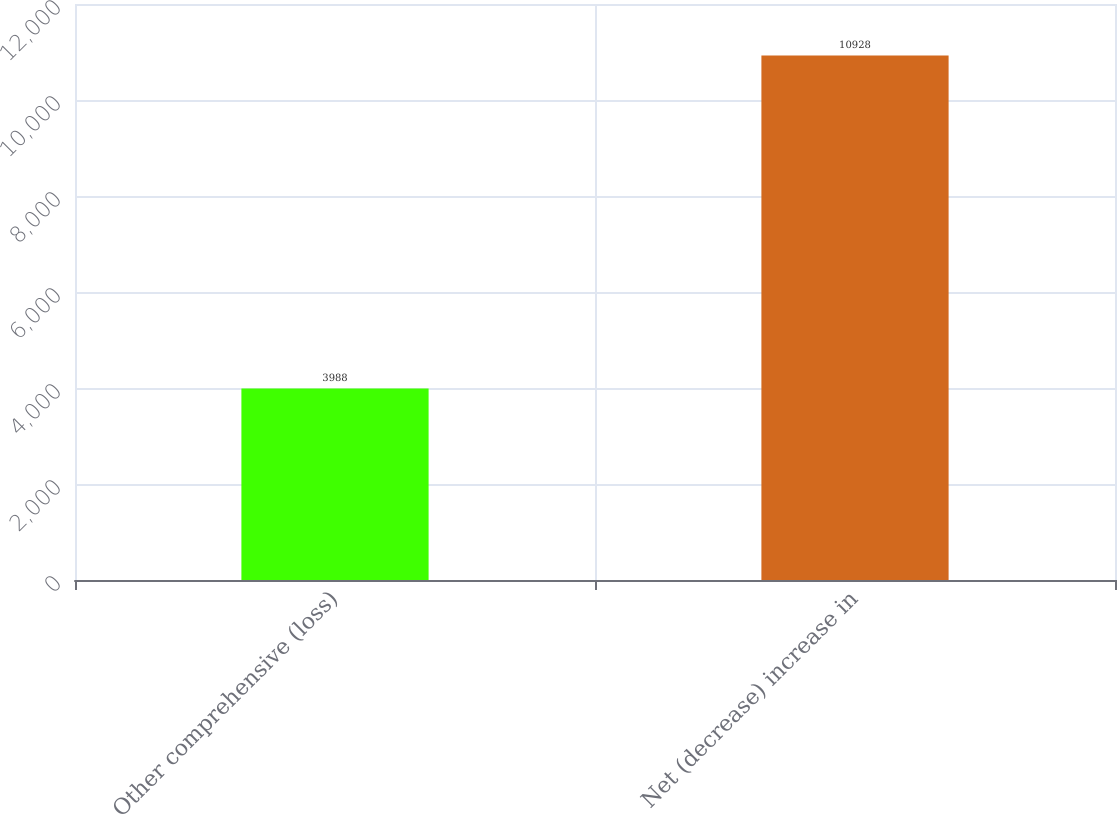Convert chart to OTSL. <chart><loc_0><loc_0><loc_500><loc_500><bar_chart><fcel>Other comprehensive (loss)<fcel>Net (decrease) increase in<nl><fcel>3988<fcel>10928<nl></chart> 